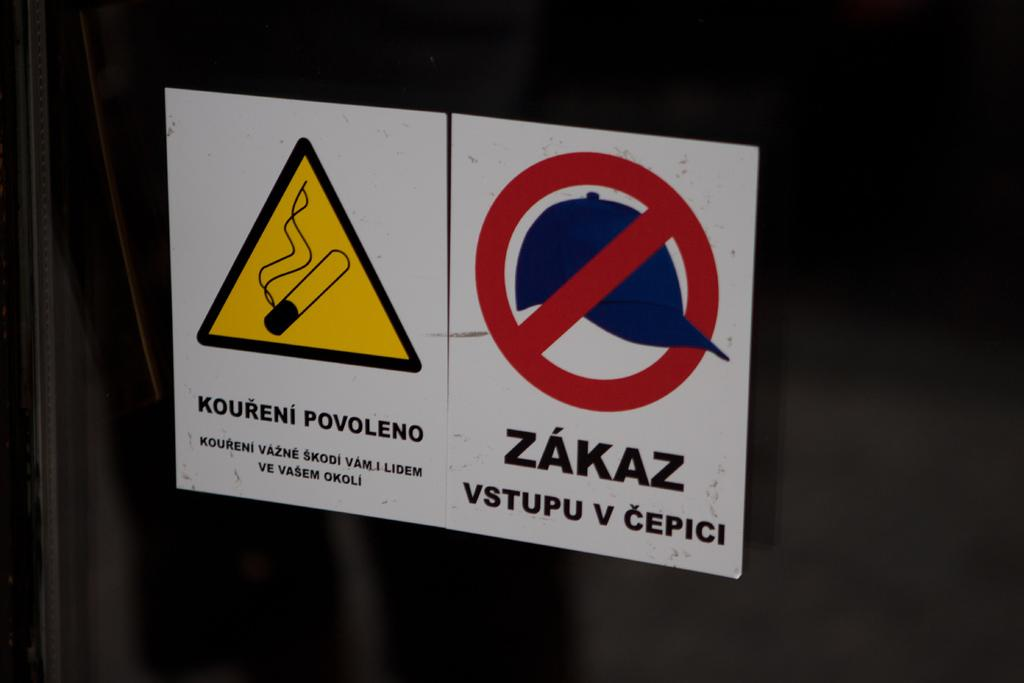<image>
Share a concise interpretation of the image provided. A sign with a cigarette in a yellow triangle reads "koureni povoleno." 